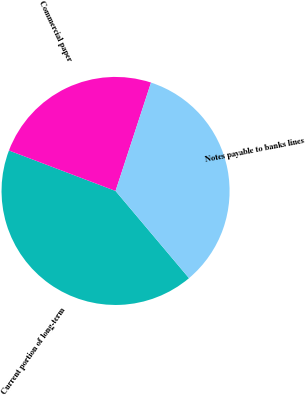Convert chart to OTSL. <chart><loc_0><loc_0><loc_500><loc_500><pie_chart><fcel>Current portion of long-term<fcel>Commercial paper<fcel>Notes payable to banks lines<nl><fcel>41.91%<fcel>24.26%<fcel>33.82%<nl></chart> 